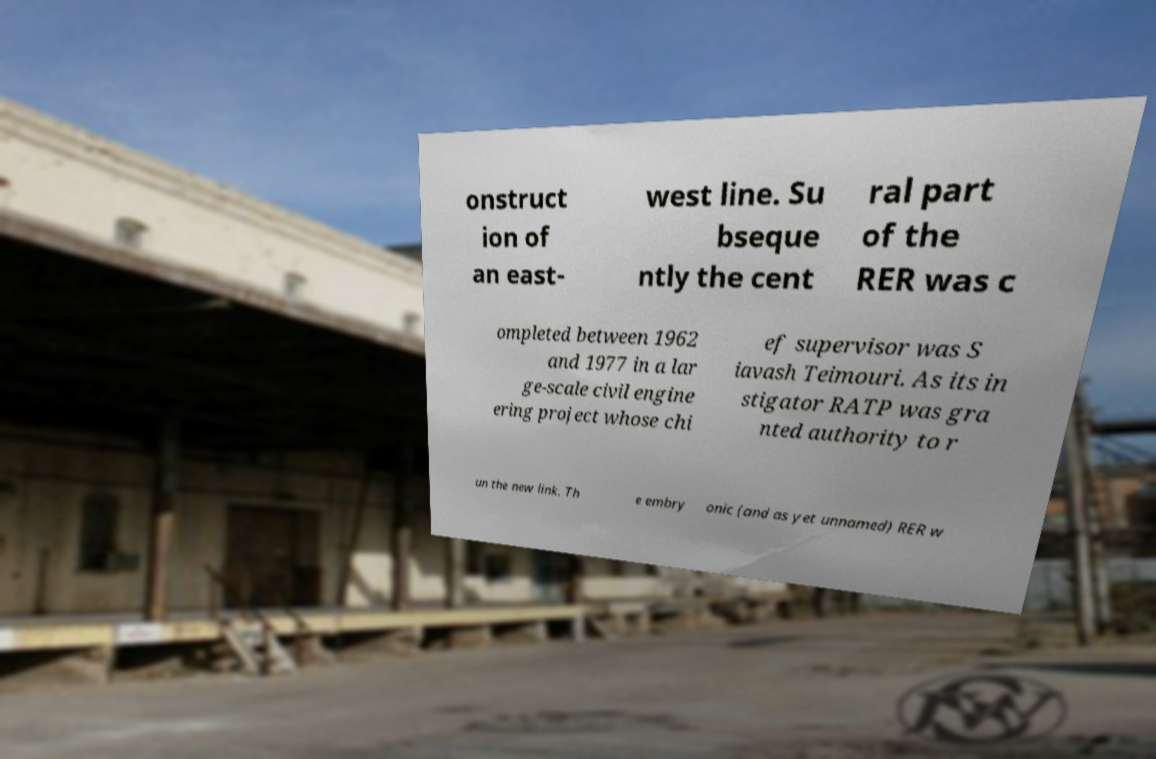Can you read and provide the text displayed in the image?This photo seems to have some interesting text. Can you extract and type it out for me? onstruct ion of an east- west line. Su bseque ntly the cent ral part of the RER was c ompleted between 1962 and 1977 in a lar ge-scale civil engine ering project whose chi ef supervisor was S iavash Teimouri. As its in stigator RATP was gra nted authority to r un the new link. Th e embry onic (and as yet unnamed) RER w 